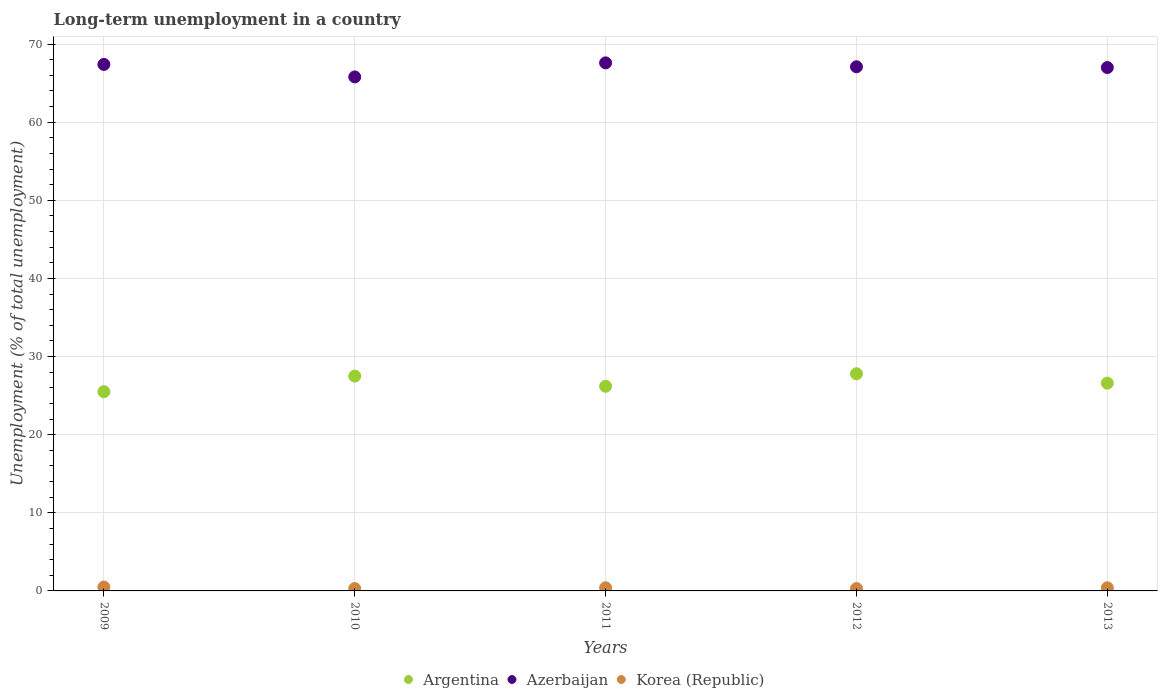Across all years, what is the maximum percentage of long-term unemployed population in Argentina?
Make the answer very short. 27.8. Across all years, what is the minimum percentage of long-term unemployed population in Argentina?
Offer a very short reply. 25.5. What is the total percentage of long-term unemployed population in Korea (Republic) in the graph?
Ensure brevity in your answer.  1.9. What is the difference between the percentage of long-term unemployed population in Korea (Republic) in 2009 and that in 2013?
Keep it short and to the point. 0.1. What is the difference between the percentage of long-term unemployed population in Argentina in 2010 and the percentage of long-term unemployed population in Azerbaijan in 2012?
Give a very brief answer. -39.6. What is the average percentage of long-term unemployed population in Azerbaijan per year?
Your answer should be compact. 66.98. In the year 2009, what is the difference between the percentage of long-term unemployed population in Argentina and percentage of long-term unemployed population in Korea (Republic)?
Provide a succinct answer. 25. In how many years, is the percentage of long-term unemployed population in Argentina greater than 46 %?
Your answer should be very brief. 0. What is the ratio of the percentage of long-term unemployed population in Azerbaijan in 2009 to that in 2010?
Give a very brief answer. 1.02. What is the difference between the highest and the second highest percentage of long-term unemployed population in Korea (Republic)?
Offer a terse response. 0.1. What is the difference between the highest and the lowest percentage of long-term unemployed population in Korea (Republic)?
Provide a short and direct response. 0.2. Is the sum of the percentage of long-term unemployed population in Azerbaijan in 2011 and 2013 greater than the maximum percentage of long-term unemployed population in Korea (Republic) across all years?
Provide a succinct answer. Yes. How many dotlines are there?
Your answer should be very brief. 3. What is the difference between two consecutive major ticks on the Y-axis?
Offer a terse response. 10. Does the graph contain any zero values?
Make the answer very short. No. Where does the legend appear in the graph?
Provide a short and direct response. Bottom center. How many legend labels are there?
Make the answer very short. 3. What is the title of the graph?
Your answer should be very brief. Long-term unemployment in a country. What is the label or title of the Y-axis?
Ensure brevity in your answer.  Unemployment (% of total unemployment). What is the Unemployment (% of total unemployment) in Azerbaijan in 2009?
Offer a very short reply. 67.4. What is the Unemployment (% of total unemployment) of Korea (Republic) in 2009?
Offer a very short reply. 0.5. What is the Unemployment (% of total unemployment) in Azerbaijan in 2010?
Offer a terse response. 65.8. What is the Unemployment (% of total unemployment) in Korea (Republic) in 2010?
Your response must be concise. 0.3. What is the Unemployment (% of total unemployment) of Argentina in 2011?
Provide a short and direct response. 26.2. What is the Unemployment (% of total unemployment) in Azerbaijan in 2011?
Your answer should be compact. 67.6. What is the Unemployment (% of total unemployment) in Korea (Republic) in 2011?
Give a very brief answer. 0.4. What is the Unemployment (% of total unemployment) in Argentina in 2012?
Make the answer very short. 27.8. What is the Unemployment (% of total unemployment) of Azerbaijan in 2012?
Make the answer very short. 67.1. What is the Unemployment (% of total unemployment) in Korea (Republic) in 2012?
Ensure brevity in your answer.  0.3. What is the Unemployment (% of total unemployment) of Argentina in 2013?
Give a very brief answer. 26.6. What is the Unemployment (% of total unemployment) in Korea (Republic) in 2013?
Your answer should be compact. 0.4. Across all years, what is the maximum Unemployment (% of total unemployment) of Argentina?
Give a very brief answer. 27.8. Across all years, what is the maximum Unemployment (% of total unemployment) in Azerbaijan?
Your answer should be very brief. 67.6. Across all years, what is the minimum Unemployment (% of total unemployment) of Argentina?
Keep it short and to the point. 25.5. Across all years, what is the minimum Unemployment (% of total unemployment) in Azerbaijan?
Give a very brief answer. 65.8. Across all years, what is the minimum Unemployment (% of total unemployment) in Korea (Republic)?
Keep it short and to the point. 0.3. What is the total Unemployment (% of total unemployment) of Argentina in the graph?
Ensure brevity in your answer.  133.6. What is the total Unemployment (% of total unemployment) of Azerbaijan in the graph?
Give a very brief answer. 334.9. What is the total Unemployment (% of total unemployment) in Korea (Republic) in the graph?
Offer a terse response. 1.9. What is the difference between the Unemployment (% of total unemployment) of Argentina in 2009 and that in 2010?
Give a very brief answer. -2. What is the difference between the Unemployment (% of total unemployment) of Azerbaijan in 2009 and that in 2010?
Your response must be concise. 1.6. What is the difference between the Unemployment (% of total unemployment) of Azerbaijan in 2009 and that in 2011?
Keep it short and to the point. -0.2. What is the difference between the Unemployment (% of total unemployment) in Azerbaijan in 2009 and that in 2012?
Offer a terse response. 0.3. What is the difference between the Unemployment (% of total unemployment) in Korea (Republic) in 2009 and that in 2012?
Offer a very short reply. 0.2. What is the difference between the Unemployment (% of total unemployment) in Azerbaijan in 2009 and that in 2013?
Your answer should be very brief. 0.4. What is the difference between the Unemployment (% of total unemployment) in Argentina in 2010 and that in 2011?
Provide a short and direct response. 1.3. What is the difference between the Unemployment (% of total unemployment) in Azerbaijan in 2010 and that in 2011?
Keep it short and to the point. -1.8. What is the difference between the Unemployment (% of total unemployment) in Korea (Republic) in 2010 and that in 2012?
Give a very brief answer. 0. What is the difference between the Unemployment (% of total unemployment) in Argentina in 2010 and that in 2013?
Keep it short and to the point. 0.9. What is the difference between the Unemployment (% of total unemployment) of Azerbaijan in 2010 and that in 2013?
Keep it short and to the point. -1.2. What is the difference between the Unemployment (% of total unemployment) of Korea (Republic) in 2011 and that in 2012?
Make the answer very short. 0.1. What is the difference between the Unemployment (% of total unemployment) of Azerbaijan in 2012 and that in 2013?
Your response must be concise. 0.1. What is the difference between the Unemployment (% of total unemployment) of Argentina in 2009 and the Unemployment (% of total unemployment) of Azerbaijan in 2010?
Your answer should be very brief. -40.3. What is the difference between the Unemployment (% of total unemployment) in Argentina in 2009 and the Unemployment (% of total unemployment) in Korea (Republic) in 2010?
Your answer should be very brief. 25.2. What is the difference between the Unemployment (% of total unemployment) in Azerbaijan in 2009 and the Unemployment (% of total unemployment) in Korea (Republic) in 2010?
Make the answer very short. 67.1. What is the difference between the Unemployment (% of total unemployment) in Argentina in 2009 and the Unemployment (% of total unemployment) in Azerbaijan in 2011?
Your answer should be very brief. -42.1. What is the difference between the Unemployment (% of total unemployment) in Argentina in 2009 and the Unemployment (% of total unemployment) in Korea (Republic) in 2011?
Your answer should be compact. 25.1. What is the difference between the Unemployment (% of total unemployment) of Argentina in 2009 and the Unemployment (% of total unemployment) of Azerbaijan in 2012?
Offer a terse response. -41.6. What is the difference between the Unemployment (% of total unemployment) in Argentina in 2009 and the Unemployment (% of total unemployment) in Korea (Republic) in 2012?
Your answer should be very brief. 25.2. What is the difference between the Unemployment (% of total unemployment) of Azerbaijan in 2009 and the Unemployment (% of total unemployment) of Korea (Republic) in 2012?
Ensure brevity in your answer.  67.1. What is the difference between the Unemployment (% of total unemployment) in Argentina in 2009 and the Unemployment (% of total unemployment) in Azerbaijan in 2013?
Make the answer very short. -41.5. What is the difference between the Unemployment (% of total unemployment) of Argentina in 2009 and the Unemployment (% of total unemployment) of Korea (Republic) in 2013?
Provide a succinct answer. 25.1. What is the difference between the Unemployment (% of total unemployment) in Argentina in 2010 and the Unemployment (% of total unemployment) in Azerbaijan in 2011?
Your response must be concise. -40.1. What is the difference between the Unemployment (% of total unemployment) of Argentina in 2010 and the Unemployment (% of total unemployment) of Korea (Republic) in 2011?
Offer a very short reply. 27.1. What is the difference between the Unemployment (% of total unemployment) of Azerbaijan in 2010 and the Unemployment (% of total unemployment) of Korea (Republic) in 2011?
Your answer should be compact. 65.4. What is the difference between the Unemployment (% of total unemployment) of Argentina in 2010 and the Unemployment (% of total unemployment) of Azerbaijan in 2012?
Your answer should be compact. -39.6. What is the difference between the Unemployment (% of total unemployment) of Argentina in 2010 and the Unemployment (% of total unemployment) of Korea (Republic) in 2012?
Offer a very short reply. 27.2. What is the difference between the Unemployment (% of total unemployment) of Azerbaijan in 2010 and the Unemployment (% of total unemployment) of Korea (Republic) in 2012?
Your answer should be very brief. 65.5. What is the difference between the Unemployment (% of total unemployment) of Argentina in 2010 and the Unemployment (% of total unemployment) of Azerbaijan in 2013?
Give a very brief answer. -39.5. What is the difference between the Unemployment (% of total unemployment) in Argentina in 2010 and the Unemployment (% of total unemployment) in Korea (Republic) in 2013?
Provide a short and direct response. 27.1. What is the difference between the Unemployment (% of total unemployment) of Azerbaijan in 2010 and the Unemployment (% of total unemployment) of Korea (Republic) in 2013?
Provide a short and direct response. 65.4. What is the difference between the Unemployment (% of total unemployment) in Argentina in 2011 and the Unemployment (% of total unemployment) in Azerbaijan in 2012?
Provide a succinct answer. -40.9. What is the difference between the Unemployment (% of total unemployment) in Argentina in 2011 and the Unemployment (% of total unemployment) in Korea (Republic) in 2012?
Offer a terse response. 25.9. What is the difference between the Unemployment (% of total unemployment) in Azerbaijan in 2011 and the Unemployment (% of total unemployment) in Korea (Republic) in 2012?
Your answer should be very brief. 67.3. What is the difference between the Unemployment (% of total unemployment) in Argentina in 2011 and the Unemployment (% of total unemployment) in Azerbaijan in 2013?
Offer a terse response. -40.8. What is the difference between the Unemployment (% of total unemployment) in Argentina in 2011 and the Unemployment (% of total unemployment) in Korea (Republic) in 2013?
Ensure brevity in your answer.  25.8. What is the difference between the Unemployment (% of total unemployment) of Azerbaijan in 2011 and the Unemployment (% of total unemployment) of Korea (Republic) in 2013?
Make the answer very short. 67.2. What is the difference between the Unemployment (% of total unemployment) in Argentina in 2012 and the Unemployment (% of total unemployment) in Azerbaijan in 2013?
Give a very brief answer. -39.2. What is the difference between the Unemployment (% of total unemployment) in Argentina in 2012 and the Unemployment (% of total unemployment) in Korea (Republic) in 2013?
Your answer should be very brief. 27.4. What is the difference between the Unemployment (% of total unemployment) in Azerbaijan in 2012 and the Unemployment (% of total unemployment) in Korea (Republic) in 2013?
Your answer should be very brief. 66.7. What is the average Unemployment (% of total unemployment) of Argentina per year?
Provide a short and direct response. 26.72. What is the average Unemployment (% of total unemployment) in Azerbaijan per year?
Ensure brevity in your answer.  66.98. What is the average Unemployment (% of total unemployment) of Korea (Republic) per year?
Make the answer very short. 0.38. In the year 2009, what is the difference between the Unemployment (% of total unemployment) in Argentina and Unemployment (% of total unemployment) in Azerbaijan?
Provide a short and direct response. -41.9. In the year 2009, what is the difference between the Unemployment (% of total unemployment) in Azerbaijan and Unemployment (% of total unemployment) in Korea (Republic)?
Your response must be concise. 66.9. In the year 2010, what is the difference between the Unemployment (% of total unemployment) in Argentina and Unemployment (% of total unemployment) in Azerbaijan?
Give a very brief answer. -38.3. In the year 2010, what is the difference between the Unemployment (% of total unemployment) of Argentina and Unemployment (% of total unemployment) of Korea (Republic)?
Provide a succinct answer. 27.2. In the year 2010, what is the difference between the Unemployment (% of total unemployment) in Azerbaijan and Unemployment (% of total unemployment) in Korea (Republic)?
Provide a short and direct response. 65.5. In the year 2011, what is the difference between the Unemployment (% of total unemployment) of Argentina and Unemployment (% of total unemployment) of Azerbaijan?
Keep it short and to the point. -41.4. In the year 2011, what is the difference between the Unemployment (% of total unemployment) of Argentina and Unemployment (% of total unemployment) of Korea (Republic)?
Your answer should be very brief. 25.8. In the year 2011, what is the difference between the Unemployment (% of total unemployment) of Azerbaijan and Unemployment (% of total unemployment) of Korea (Republic)?
Keep it short and to the point. 67.2. In the year 2012, what is the difference between the Unemployment (% of total unemployment) of Argentina and Unemployment (% of total unemployment) of Azerbaijan?
Ensure brevity in your answer.  -39.3. In the year 2012, what is the difference between the Unemployment (% of total unemployment) in Argentina and Unemployment (% of total unemployment) in Korea (Republic)?
Provide a short and direct response. 27.5. In the year 2012, what is the difference between the Unemployment (% of total unemployment) of Azerbaijan and Unemployment (% of total unemployment) of Korea (Republic)?
Provide a succinct answer. 66.8. In the year 2013, what is the difference between the Unemployment (% of total unemployment) of Argentina and Unemployment (% of total unemployment) of Azerbaijan?
Provide a short and direct response. -40.4. In the year 2013, what is the difference between the Unemployment (% of total unemployment) in Argentina and Unemployment (% of total unemployment) in Korea (Republic)?
Ensure brevity in your answer.  26.2. In the year 2013, what is the difference between the Unemployment (% of total unemployment) in Azerbaijan and Unemployment (% of total unemployment) in Korea (Republic)?
Ensure brevity in your answer.  66.6. What is the ratio of the Unemployment (% of total unemployment) of Argentina in 2009 to that in 2010?
Provide a succinct answer. 0.93. What is the ratio of the Unemployment (% of total unemployment) in Azerbaijan in 2009 to that in 2010?
Provide a short and direct response. 1.02. What is the ratio of the Unemployment (% of total unemployment) of Korea (Republic) in 2009 to that in 2010?
Your answer should be compact. 1.67. What is the ratio of the Unemployment (% of total unemployment) in Argentina in 2009 to that in 2011?
Give a very brief answer. 0.97. What is the ratio of the Unemployment (% of total unemployment) in Argentina in 2009 to that in 2012?
Give a very brief answer. 0.92. What is the ratio of the Unemployment (% of total unemployment) of Azerbaijan in 2009 to that in 2012?
Your answer should be compact. 1. What is the ratio of the Unemployment (% of total unemployment) in Korea (Republic) in 2009 to that in 2012?
Your answer should be very brief. 1.67. What is the ratio of the Unemployment (% of total unemployment) in Argentina in 2009 to that in 2013?
Your response must be concise. 0.96. What is the ratio of the Unemployment (% of total unemployment) of Korea (Republic) in 2009 to that in 2013?
Make the answer very short. 1.25. What is the ratio of the Unemployment (% of total unemployment) in Argentina in 2010 to that in 2011?
Offer a terse response. 1.05. What is the ratio of the Unemployment (% of total unemployment) of Azerbaijan in 2010 to that in 2011?
Your answer should be compact. 0.97. What is the ratio of the Unemployment (% of total unemployment) of Azerbaijan in 2010 to that in 2012?
Provide a short and direct response. 0.98. What is the ratio of the Unemployment (% of total unemployment) in Argentina in 2010 to that in 2013?
Offer a very short reply. 1.03. What is the ratio of the Unemployment (% of total unemployment) of Azerbaijan in 2010 to that in 2013?
Provide a succinct answer. 0.98. What is the ratio of the Unemployment (% of total unemployment) of Korea (Republic) in 2010 to that in 2013?
Keep it short and to the point. 0.75. What is the ratio of the Unemployment (% of total unemployment) in Argentina in 2011 to that in 2012?
Provide a short and direct response. 0.94. What is the ratio of the Unemployment (% of total unemployment) of Azerbaijan in 2011 to that in 2012?
Provide a short and direct response. 1.01. What is the ratio of the Unemployment (% of total unemployment) of Argentina in 2012 to that in 2013?
Your answer should be compact. 1.05. What is the ratio of the Unemployment (% of total unemployment) of Korea (Republic) in 2012 to that in 2013?
Your response must be concise. 0.75. What is the difference between the highest and the second highest Unemployment (% of total unemployment) of Argentina?
Your answer should be very brief. 0.3. What is the difference between the highest and the second highest Unemployment (% of total unemployment) of Korea (Republic)?
Offer a very short reply. 0.1. What is the difference between the highest and the lowest Unemployment (% of total unemployment) in Korea (Republic)?
Ensure brevity in your answer.  0.2. 